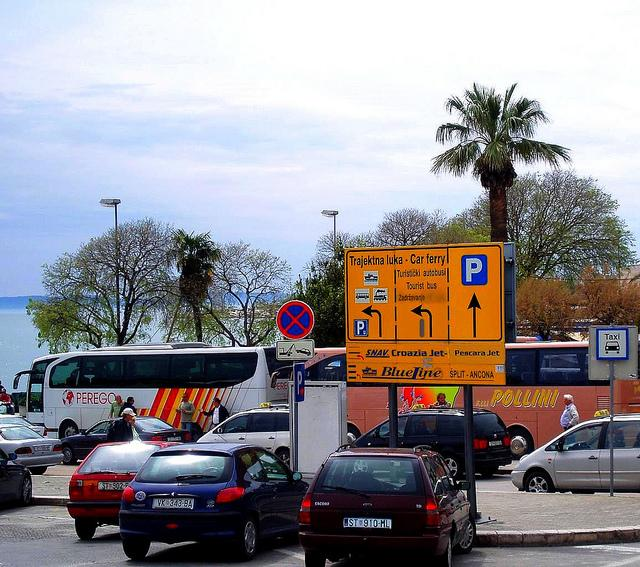How might cars cross the water seen here? ferry 